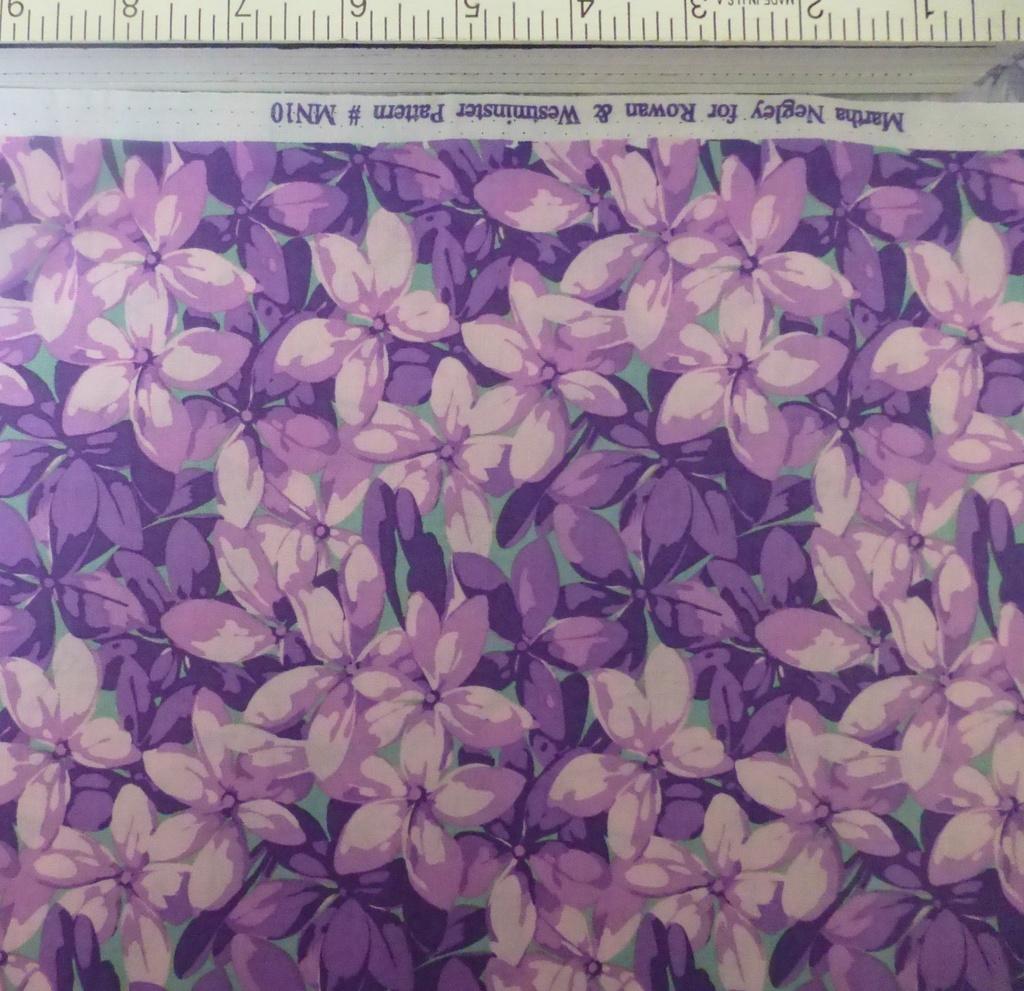In one or two sentences, can you explain what this image depicts? In this picture we can see a measuring object, painting of flowers and some text. 